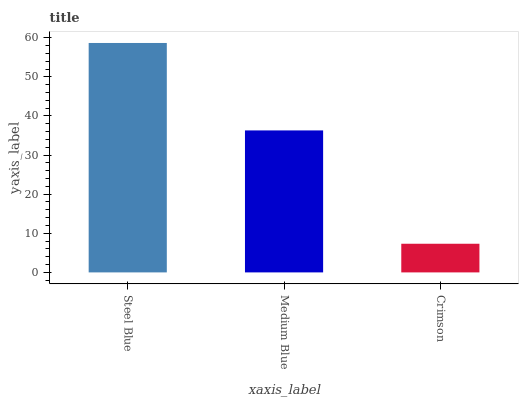Is Crimson the minimum?
Answer yes or no. Yes. Is Steel Blue the maximum?
Answer yes or no. Yes. Is Medium Blue the minimum?
Answer yes or no. No. Is Medium Blue the maximum?
Answer yes or no. No. Is Steel Blue greater than Medium Blue?
Answer yes or no. Yes. Is Medium Blue less than Steel Blue?
Answer yes or no. Yes. Is Medium Blue greater than Steel Blue?
Answer yes or no. No. Is Steel Blue less than Medium Blue?
Answer yes or no. No. Is Medium Blue the high median?
Answer yes or no. Yes. Is Medium Blue the low median?
Answer yes or no. Yes. Is Steel Blue the high median?
Answer yes or no. No. Is Crimson the low median?
Answer yes or no. No. 